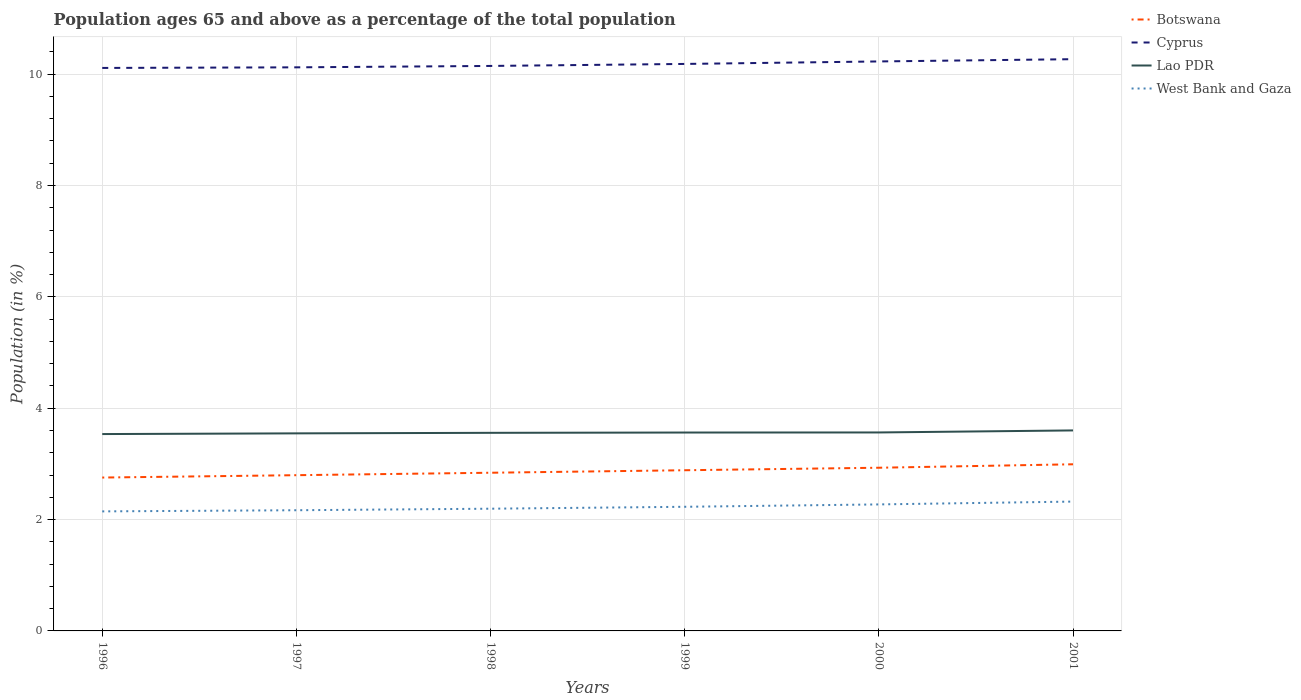How many different coloured lines are there?
Keep it short and to the point. 4. Does the line corresponding to Lao PDR intersect with the line corresponding to Botswana?
Your response must be concise. No. Across all years, what is the maximum percentage of the population ages 65 and above in West Bank and Gaza?
Provide a short and direct response. 2.15. In which year was the percentage of the population ages 65 and above in Cyprus maximum?
Give a very brief answer. 1996. What is the total percentage of the population ages 65 and above in Cyprus in the graph?
Your answer should be very brief. -0.15. What is the difference between the highest and the second highest percentage of the population ages 65 and above in Lao PDR?
Ensure brevity in your answer.  0.07. What is the difference between the highest and the lowest percentage of the population ages 65 and above in West Bank and Gaza?
Your response must be concise. 3. How many lines are there?
Keep it short and to the point. 4. What is the difference between two consecutive major ticks on the Y-axis?
Provide a short and direct response. 2. Does the graph contain grids?
Keep it short and to the point. Yes. Where does the legend appear in the graph?
Provide a short and direct response. Top right. How are the legend labels stacked?
Provide a succinct answer. Vertical. What is the title of the graph?
Your answer should be very brief. Population ages 65 and above as a percentage of the total population. Does "San Marino" appear as one of the legend labels in the graph?
Offer a terse response. No. What is the label or title of the Y-axis?
Provide a short and direct response. Population (in %). What is the Population (in %) in Botswana in 1996?
Ensure brevity in your answer.  2.75. What is the Population (in %) of Cyprus in 1996?
Make the answer very short. 10.11. What is the Population (in %) in Lao PDR in 1996?
Provide a short and direct response. 3.54. What is the Population (in %) of West Bank and Gaza in 1996?
Keep it short and to the point. 2.15. What is the Population (in %) of Botswana in 1997?
Your answer should be very brief. 2.8. What is the Population (in %) of Cyprus in 1997?
Make the answer very short. 10.12. What is the Population (in %) of Lao PDR in 1997?
Offer a terse response. 3.55. What is the Population (in %) in West Bank and Gaza in 1997?
Ensure brevity in your answer.  2.17. What is the Population (in %) of Botswana in 1998?
Your answer should be very brief. 2.84. What is the Population (in %) of Cyprus in 1998?
Your response must be concise. 10.15. What is the Population (in %) in Lao PDR in 1998?
Your response must be concise. 3.56. What is the Population (in %) in West Bank and Gaza in 1998?
Make the answer very short. 2.2. What is the Population (in %) in Botswana in 1999?
Your answer should be very brief. 2.89. What is the Population (in %) in Cyprus in 1999?
Ensure brevity in your answer.  10.18. What is the Population (in %) in Lao PDR in 1999?
Your response must be concise. 3.56. What is the Population (in %) of West Bank and Gaza in 1999?
Make the answer very short. 2.23. What is the Population (in %) in Botswana in 2000?
Your response must be concise. 2.93. What is the Population (in %) in Cyprus in 2000?
Make the answer very short. 10.23. What is the Population (in %) in Lao PDR in 2000?
Keep it short and to the point. 3.56. What is the Population (in %) in West Bank and Gaza in 2000?
Provide a succinct answer. 2.27. What is the Population (in %) of Botswana in 2001?
Offer a very short reply. 2.99. What is the Population (in %) of Cyprus in 2001?
Give a very brief answer. 10.27. What is the Population (in %) of Lao PDR in 2001?
Offer a very short reply. 3.6. What is the Population (in %) of West Bank and Gaza in 2001?
Make the answer very short. 2.32. Across all years, what is the maximum Population (in %) of Botswana?
Your answer should be very brief. 2.99. Across all years, what is the maximum Population (in %) in Cyprus?
Give a very brief answer. 10.27. Across all years, what is the maximum Population (in %) in Lao PDR?
Your answer should be compact. 3.6. Across all years, what is the maximum Population (in %) of West Bank and Gaza?
Your answer should be very brief. 2.32. Across all years, what is the minimum Population (in %) in Botswana?
Offer a terse response. 2.75. Across all years, what is the minimum Population (in %) in Cyprus?
Give a very brief answer. 10.11. Across all years, what is the minimum Population (in %) in Lao PDR?
Make the answer very short. 3.54. Across all years, what is the minimum Population (in %) in West Bank and Gaza?
Provide a short and direct response. 2.15. What is the total Population (in %) of Botswana in the graph?
Make the answer very short. 17.2. What is the total Population (in %) of Cyprus in the graph?
Your response must be concise. 61.06. What is the total Population (in %) of Lao PDR in the graph?
Keep it short and to the point. 21.37. What is the total Population (in %) in West Bank and Gaza in the graph?
Ensure brevity in your answer.  13.34. What is the difference between the Population (in %) in Botswana in 1996 and that in 1997?
Offer a very short reply. -0.04. What is the difference between the Population (in %) of Cyprus in 1996 and that in 1997?
Your response must be concise. -0.01. What is the difference between the Population (in %) in Lao PDR in 1996 and that in 1997?
Your answer should be compact. -0.01. What is the difference between the Population (in %) of West Bank and Gaza in 1996 and that in 1997?
Offer a very short reply. -0.02. What is the difference between the Population (in %) of Botswana in 1996 and that in 1998?
Your answer should be very brief. -0.09. What is the difference between the Population (in %) of Cyprus in 1996 and that in 1998?
Provide a short and direct response. -0.04. What is the difference between the Population (in %) in Lao PDR in 1996 and that in 1998?
Your answer should be very brief. -0.02. What is the difference between the Population (in %) of West Bank and Gaza in 1996 and that in 1998?
Keep it short and to the point. -0.05. What is the difference between the Population (in %) in Botswana in 1996 and that in 1999?
Give a very brief answer. -0.13. What is the difference between the Population (in %) of Cyprus in 1996 and that in 1999?
Ensure brevity in your answer.  -0.07. What is the difference between the Population (in %) of Lao PDR in 1996 and that in 1999?
Provide a short and direct response. -0.03. What is the difference between the Population (in %) of West Bank and Gaza in 1996 and that in 1999?
Your response must be concise. -0.08. What is the difference between the Population (in %) of Botswana in 1996 and that in 2000?
Your response must be concise. -0.18. What is the difference between the Population (in %) of Cyprus in 1996 and that in 2000?
Make the answer very short. -0.12. What is the difference between the Population (in %) in Lao PDR in 1996 and that in 2000?
Your answer should be compact. -0.03. What is the difference between the Population (in %) in West Bank and Gaza in 1996 and that in 2000?
Provide a succinct answer. -0.13. What is the difference between the Population (in %) of Botswana in 1996 and that in 2001?
Your answer should be very brief. -0.24. What is the difference between the Population (in %) of Cyprus in 1996 and that in 2001?
Your response must be concise. -0.16. What is the difference between the Population (in %) in Lao PDR in 1996 and that in 2001?
Your answer should be compact. -0.07. What is the difference between the Population (in %) of West Bank and Gaza in 1996 and that in 2001?
Give a very brief answer. -0.18. What is the difference between the Population (in %) of Botswana in 1997 and that in 1998?
Offer a terse response. -0.04. What is the difference between the Population (in %) of Cyprus in 1997 and that in 1998?
Offer a terse response. -0.03. What is the difference between the Population (in %) in Lao PDR in 1997 and that in 1998?
Your answer should be compact. -0.01. What is the difference between the Population (in %) in West Bank and Gaza in 1997 and that in 1998?
Your response must be concise. -0.03. What is the difference between the Population (in %) of Botswana in 1997 and that in 1999?
Provide a succinct answer. -0.09. What is the difference between the Population (in %) of Cyprus in 1997 and that in 1999?
Your answer should be very brief. -0.06. What is the difference between the Population (in %) of Lao PDR in 1997 and that in 1999?
Offer a terse response. -0.01. What is the difference between the Population (in %) of West Bank and Gaza in 1997 and that in 1999?
Your answer should be compact. -0.06. What is the difference between the Population (in %) of Botswana in 1997 and that in 2000?
Your response must be concise. -0.13. What is the difference between the Population (in %) in Cyprus in 1997 and that in 2000?
Make the answer very short. -0.11. What is the difference between the Population (in %) of Lao PDR in 1997 and that in 2000?
Offer a very short reply. -0.02. What is the difference between the Population (in %) of West Bank and Gaza in 1997 and that in 2000?
Ensure brevity in your answer.  -0.1. What is the difference between the Population (in %) in Botswana in 1997 and that in 2001?
Offer a very short reply. -0.2. What is the difference between the Population (in %) in Cyprus in 1997 and that in 2001?
Offer a terse response. -0.15. What is the difference between the Population (in %) of Lao PDR in 1997 and that in 2001?
Offer a terse response. -0.05. What is the difference between the Population (in %) of West Bank and Gaza in 1997 and that in 2001?
Your answer should be compact. -0.16. What is the difference between the Population (in %) of Botswana in 1998 and that in 1999?
Provide a short and direct response. -0.04. What is the difference between the Population (in %) in Cyprus in 1998 and that in 1999?
Ensure brevity in your answer.  -0.04. What is the difference between the Population (in %) in Lao PDR in 1998 and that in 1999?
Keep it short and to the point. -0.01. What is the difference between the Population (in %) in West Bank and Gaza in 1998 and that in 1999?
Make the answer very short. -0.03. What is the difference between the Population (in %) of Botswana in 1998 and that in 2000?
Offer a terse response. -0.09. What is the difference between the Population (in %) in Cyprus in 1998 and that in 2000?
Keep it short and to the point. -0.08. What is the difference between the Population (in %) in Lao PDR in 1998 and that in 2000?
Offer a terse response. -0.01. What is the difference between the Population (in %) in West Bank and Gaza in 1998 and that in 2000?
Provide a short and direct response. -0.08. What is the difference between the Population (in %) in Botswana in 1998 and that in 2001?
Offer a terse response. -0.15. What is the difference between the Population (in %) of Cyprus in 1998 and that in 2001?
Provide a succinct answer. -0.12. What is the difference between the Population (in %) in Lao PDR in 1998 and that in 2001?
Offer a very short reply. -0.04. What is the difference between the Population (in %) of West Bank and Gaza in 1998 and that in 2001?
Give a very brief answer. -0.13. What is the difference between the Population (in %) of Botswana in 1999 and that in 2000?
Give a very brief answer. -0.04. What is the difference between the Population (in %) in Cyprus in 1999 and that in 2000?
Offer a terse response. -0.04. What is the difference between the Population (in %) of Lao PDR in 1999 and that in 2000?
Make the answer very short. -0. What is the difference between the Population (in %) of West Bank and Gaza in 1999 and that in 2000?
Provide a short and direct response. -0.04. What is the difference between the Population (in %) in Botswana in 1999 and that in 2001?
Your response must be concise. -0.11. What is the difference between the Population (in %) in Cyprus in 1999 and that in 2001?
Offer a very short reply. -0.09. What is the difference between the Population (in %) in Lao PDR in 1999 and that in 2001?
Ensure brevity in your answer.  -0.04. What is the difference between the Population (in %) of West Bank and Gaza in 1999 and that in 2001?
Offer a very short reply. -0.09. What is the difference between the Population (in %) in Botswana in 2000 and that in 2001?
Keep it short and to the point. -0.06. What is the difference between the Population (in %) of Cyprus in 2000 and that in 2001?
Your response must be concise. -0.04. What is the difference between the Population (in %) in Lao PDR in 2000 and that in 2001?
Keep it short and to the point. -0.04. What is the difference between the Population (in %) of West Bank and Gaza in 2000 and that in 2001?
Your answer should be compact. -0.05. What is the difference between the Population (in %) of Botswana in 1996 and the Population (in %) of Cyprus in 1997?
Your answer should be very brief. -7.37. What is the difference between the Population (in %) of Botswana in 1996 and the Population (in %) of Lao PDR in 1997?
Keep it short and to the point. -0.79. What is the difference between the Population (in %) of Botswana in 1996 and the Population (in %) of West Bank and Gaza in 1997?
Ensure brevity in your answer.  0.59. What is the difference between the Population (in %) of Cyprus in 1996 and the Population (in %) of Lao PDR in 1997?
Ensure brevity in your answer.  6.56. What is the difference between the Population (in %) in Cyprus in 1996 and the Population (in %) in West Bank and Gaza in 1997?
Ensure brevity in your answer.  7.94. What is the difference between the Population (in %) in Lao PDR in 1996 and the Population (in %) in West Bank and Gaza in 1997?
Your answer should be very brief. 1.37. What is the difference between the Population (in %) in Botswana in 1996 and the Population (in %) in Cyprus in 1998?
Your answer should be compact. -7.39. What is the difference between the Population (in %) in Botswana in 1996 and the Population (in %) in Lao PDR in 1998?
Ensure brevity in your answer.  -0.8. What is the difference between the Population (in %) in Botswana in 1996 and the Population (in %) in West Bank and Gaza in 1998?
Keep it short and to the point. 0.56. What is the difference between the Population (in %) in Cyprus in 1996 and the Population (in %) in Lao PDR in 1998?
Your answer should be compact. 6.55. What is the difference between the Population (in %) of Cyprus in 1996 and the Population (in %) of West Bank and Gaza in 1998?
Provide a succinct answer. 7.92. What is the difference between the Population (in %) in Lao PDR in 1996 and the Population (in %) in West Bank and Gaza in 1998?
Offer a terse response. 1.34. What is the difference between the Population (in %) of Botswana in 1996 and the Population (in %) of Cyprus in 1999?
Make the answer very short. -7.43. What is the difference between the Population (in %) in Botswana in 1996 and the Population (in %) in Lao PDR in 1999?
Offer a terse response. -0.81. What is the difference between the Population (in %) of Botswana in 1996 and the Population (in %) of West Bank and Gaza in 1999?
Make the answer very short. 0.53. What is the difference between the Population (in %) of Cyprus in 1996 and the Population (in %) of Lao PDR in 1999?
Offer a terse response. 6.55. What is the difference between the Population (in %) of Cyprus in 1996 and the Population (in %) of West Bank and Gaza in 1999?
Your answer should be compact. 7.88. What is the difference between the Population (in %) of Lao PDR in 1996 and the Population (in %) of West Bank and Gaza in 1999?
Give a very brief answer. 1.31. What is the difference between the Population (in %) in Botswana in 1996 and the Population (in %) in Cyprus in 2000?
Your response must be concise. -7.47. What is the difference between the Population (in %) in Botswana in 1996 and the Population (in %) in Lao PDR in 2000?
Provide a succinct answer. -0.81. What is the difference between the Population (in %) in Botswana in 1996 and the Population (in %) in West Bank and Gaza in 2000?
Offer a terse response. 0.48. What is the difference between the Population (in %) in Cyprus in 1996 and the Population (in %) in Lao PDR in 2000?
Ensure brevity in your answer.  6.55. What is the difference between the Population (in %) of Cyprus in 1996 and the Population (in %) of West Bank and Gaza in 2000?
Provide a short and direct response. 7.84. What is the difference between the Population (in %) of Lao PDR in 1996 and the Population (in %) of West Bank and Gaza in 2000?
Your response must be concise. 1.26. What is the difference between the Population (in %) of Botswana in 1996 and the Population (in %) of Cyprus in 2001?
Your answer should be compact. -7.51. What is the difference between the Population (in %) of Botswana in 1996 and the Population (in %) of Lao PDR in 2001?
Offer a very short reply. -0.85. What is the difference between the Population (in %) in Botswana in 1996 and the Population (in %) in West Bank and Gaza in 2001?
Keep it short and to the point. 0.43. What is the difference between the Population (in %) in Cyprus in 1996 and the Population (in %) in Lao PDR in 2001?
Offer a very short reply. 6.51. What is the difference between the Population (in %) in Cyprus in 1996 and the Population (in %) in West Bank and Gaza in 2001?
Provide a succinct answer. 7.79. What is the difference between the Population (in %) of Lao PDR in 1996 and the Population (in %) of West Bank and Gaza in 2001?
Ensure brevity in your answer.  1.21. What is the difference between the Population (in %) of Botswana in 1997 and the Population (in %) of Cyprus in 1998?
Make the answer very short. -7.35. What is the difference between the Population (in %) of Botswana in 1997 and the Population (in %) of Lao PDR in 1998?
Offer a terse response. -0.76. What is the difference between the Population (in %) of Botswana in 1997 and the Population (in %) of West Bank and Gaza in 1998?
Provide a short and direct response. 0.6. What is the difference between the Population (in %) of Cyprus in 1997 and the Population (in %) of Lao PDR in 1998?
Keep it short and to the point. 6.56. What is the difference between the Population (in %) of Cyprus in 1997 and the Population (in %) of West Bank and Gaza in 1998?
Keep it short and to the point. 7.93. What is the difference between the Population (in %) of Lao PDR in 1997 and the Population (in %) of West Bank and Gaza in 1998?
Offer a very short reply. 1.35. What is the difference between the Population (in %) in Botswana in 1997 and the Population (in %) in Cyprus in 1999?
Give a very brief answer. -7.39. What is the difference between the Population (in %) in Botswana in 1997 and the Population (in %) in Lao PDR in 1999?
Make the answer very short. -0.77. What is the difference between the Population (in %) of Botswana in 1997 and the Population (in %) of West Bank and Gaza in 1999?
Provide a succinct answer. 0.57. What is the difference between the Population (in %) in Cyprus in 1997 and the Population (in %) in Lao PDR in 1999?
Offer a very short reply. 6.56. What is the difference between the Population (in %) of Cyprus in 1997 and the Population (in %) of West Bank and Gaza in 1999?
Give a very brief answer. 7.89. What is the difference between the Population (in %) of Lao PDR in 1997 and the Population (in %) of West Bank and Gaza in 1999?
Ensure brevity in your answer.  1.32. What is the difference between the Population (in %) in Botswana in 1997 and the Population (in %) in Cyprus in 2000?
Your answer should be very brief. -7.43. What is the difference between the Population (in %) of Botswana in 1997 and the Population (in %) of Lao PDR in 2000?
Your response must be concise. -0.77. What is the difference between the Population (in %) in Botswana in 1997 and the Population (in %) in West Bank and Gaza in 2000?
Offer a terse response. 0.53. What is the difference between the Population (in %) in Cyprus in 1997 and the Population (in %) in Lao PDR in 2000?
Your answer should be compact. 6.56. What is the difference between the Population (in %) in Cyprus in 1997 and the Population (in %) in West Bank and Gaza in 2000?
Provide a short and direct response. 7.85. What is the difference between the Population (in %) of Lao PDR in 1997 and the Population (in %) of West Bank and Gaza in 2000?
Provide a short and direct response. 1.28. What is the difference between the Population (in %) in Botswana in 1997 and the Population (in %) in Cyprus in 2001?
Your answer should be compact. -7.47. What is the difference between the Population (in %) of Botswana in 1997 and the Population (in %) of Lao PDR in 2001?
Your answer should be compact. -0.8. What is the difference between the Population (in %) in Botswana in 1997 and the Population (in %) in West Bank and Gaza in 2001?
Give a very brief answer. 0.47. What is the difference between the Population (in %) in Cyprus in 1997 and the Population (in %) in Lao PDR in 2001?
Your response must be concise. 6.52. What is the difference between the Population (in %) in Cyprus in 1997 and the Population (in %) in West Bank and Gaza in 2001?
Your response must be concise. 7.8. What is the difference between the Population (in %) in Lao PDR in 1997 and the Population (in %) in West Bank and Gaza in 2001?
Make the answer very short. 1.23. What is the difference between the Population (in %) of Botswana in 1998 and the Population (in %) of Cyprus in 1999?
Give a very brief answer. -7.34. What is the difference between the Population (in %) in Botswana in 1998 and the Population (in %) in Lao PDR in 1999?
Provide a short and direct response. -0.72. What is the difference between the Population (in %) in Botswana in 1998 and the Population (in %) in West Bank and Gaza in 1999?
Offer a terse response. 0.61. What is the difference between the Population (in %) of Cyprus in 1998 and the Population (in %) of Lao PDR in 1999?
Your response must be concise. 6.58. What is the difference between the Population (in %) in Cyprus in 1998 and the Population (in %) in West Bank and Gaza in 1999?
Give a very brief answer. 7.92. What is the difference between the Population (in %) of Lao PDR in 1998 and the Population (in %) of West Bank and Gaza in 1999?
Your answer should be compact. 1.33. What is the difference between the Population (in %) in Botswana in 1998 and the Population (in %) in Cyprus in 2000?
Keep it short and to the point. -7.39. What is the difference between the Population (in %) in Botswana in 1998 and the Population (in %) in Lao PDR in 2000?
Provide a succinct answer. -0.72. What is the difference between the Population (in %) of Botswana in 1998 and the Population (in %) of West Bank and Gaza in 2000?
Provide a succinct answer. 0.57. What is the difference between the Population (in %) of Cyprus in 1998 and the Population (in %) of Lao PDR in 2000?
Your answer should be compact. 6.58. What is the difference between the Population (in %) of Cyprus in 1998 and the Population (in %) of West Bank and Gaza in 2000?
Your answer should be compact. 7.88. What is the difference between the Population (in %) in Lao PDR in 1998 and the Population (in %) in West Bank and Gaza in 2000?
Provide a short and direct response. 1.29. What is the difference between the Population (in %) in Botswana in 1998 and the Population (in %) in Cyprus in 2001?
Your response must be concise. -7.43. What is the difference between the Population (in %) in Botswana in 1998 and the Population (in %) in Lao PDR in 2001?
Offer a terse response. -0.76. What is the difference between the Population (in %) of Botswana in 1998 and the Population (in %) of West Bank and Gaza in 2001?
Make the answer very short. 0.52. What is the difference between the Population (in %) of Cyprus in 1998 and the Population (in %) of Lao PDR in 2001?
Your answer should be very brief. 6.55. What is the difference between the Population (in %) in Cyprus in 1998 and the Population (in %) in West Bank and Gaza in 2001?
Your response must be concise. 7.82. What is the difference between the Population (in %) of Lao PDR in 1998 and the Population (in %) of West Bank and Gaza in 2001?
Offer a very short reply. 1.23. What is the difference between the Population (in %) of Botswana in 1999 and the Population (in %) of Cyprus in 2000?
Ensure brevity in your answer.  -7.34. What is the difference between the Population (in %) in Botswana in 1999 and the Population (in %) in Lao PDR in 2000?
Provide a short and direct response. -0.68. What is the difference between the Population (in %) in Botswana in 1999 and the Population (in %) in West Bank and Gaza in 2000?
Give a very brief answer. 0.61. What is the difference between the Population (in %) in Cyprus in 1999 and the Population (in %) in Lao PDR in 2000?
Keep it short and to the point. 6.62. What is the difference between the Population (in %) in Cyprus in 1999 and the Population (in %) in West Bank and Gaza in 2000?
Offer a very short reply. 7.91. What is the difference between the Population (in %) of Lao PDR in 1999 and the Population (in %) of West Bank and Gaza in 2000?
Make the answer very short. 1.29. What is the difference between the Population (in %) of Botswana in 1999 and the Population (in %) of Cyprus in 2001?
Provide a succinct answer. -7.38. What is the difference between the Population (in %) in Botswana in 1999 and the Population (in %) in Lao PDR in 2001?
Give a very brief answer. -0.72. What is the difference between the Population (in %) of Botswana in 1999 and the Population (in %) of West Bank and Gaza in 2001?
Offer a very short reply. 0.56. What is the difference between the Population (in %) in Cyprus in 1999 and the Population (in %) in Lao PDR in 2001?
Your answer should be very brief. 6.58. What is the difference between the Population (in %) in Cyprus in 1999 and the Population (in %) in West Bank and Gaza in 2001?
Your answer should be very brief. 7.86. What is the difference between the Population (in %) of Lao PDR in 1999 and the Population (in %) of West Bank and Gaza in 2001?
Provide a short and direct response. 1.24. What is the difference between the Population (in %) in Botswana in 2000 and the Population (in %) in Cyprus in 2001?
Keep it short and to the point. -7.34. What is the difference between the Population (in %) of Botswana in 2000 and the Population (in %) of Lao PDR in 2001?
Give a very brief answer. -0.67. What is the difference between the Population (in %) in Botswana in 2000 and the Population (in %) in West Bank and Gaza in 2001?
Make the answer very short. 0.61. What is the difference between the Population (in %) of Cyprus in 2000 and the Population (in %) of Lao PDR in 2001?
Make the answer very short. 6.63. What is the difference between the Population (in %) in Cyprus in 2000 and the Population (in %) in West Bank and Gaza in 2001?
Your response must be concise. 7.91. What is the difference between the Population (in %) in Lao PDR in 2000 and the Population (in %) in West Bank and Gaza in 2001?
Your response must be concise. 1.24. What is the average Population (in %) in Botswana per year?
Keep it short and to the point. 2.87. What is the average Population (in %) of Cyprus per year?
Give a very brief answer. 10.18. What is the average Population (in %) in Lao PDR per year?
Provide a short and direct response. 3.56. What is the average Population (in %) in West Bank and Gaza per year?
Offer a terse response. 2.22. In the year 1996, what is the difference between the Population (in %) of Botswana and Population (in %) of Cyprus?
Your answer should be very brief. -7.36. In the year 1996, what is the difference between the Population (in %) of Botswana and Population (in %) of Lao PDR?
Ensure brevity in your answer.  -0.78. In the year 1996, what is the difference between the Population (in %) of Botswana and Population (in %) of West Bank and Gaza?
Your response must be concise. 0.61. In the year 1996, what is the difference between the Population (in %) of Cyprus and Population (in %) of Lao PDR?
Your answer should be very brief. 6.58. In the year 1996, what is the difference between the Population (in %) of Cyprus and Population (in %) of West Bank and Gaza?
Your answer should be compact. 7.96. In the year 1996, what is the difference between the Population (in %) in Lao PDR and Population (in %) in West Bank and Gaza?
Make the answer very short. 1.39. In the year 1997, what is the difference between the Population (in %) of Botswana and Population (in %) of Cyprus?
Your response must be concise. -7.33. In the year 1997, what is the difference between the Population (in %) of Botswana and Population (in %) of Lao PDR?
Keep it short and to the point. -0.75. In the year 1997, what is the difference between the Population (in %) in Botswana and Population (in %) in West Bank and Gaza?
Provide a short and direct response. 0.63. In the year 1997, what is the difference between the Population (in %) of Cyprus and Population (in %) of Lao PDR?
Your answer should be compact. 6.57. In the year 1997, what is the difference between the Population (in %) of Cyprus and Population (in %) of West Bank and Gaza?
Your answer should be very brief. 7.96. In the year 1997, what is the difference between the Population (in %) of Lao PDR and Population (in %) of West Bank and Gaza?
Ensure brevity in your answer.  1.38. In the year 1998, what is the difference between the Population (in %) of Botswana and Population (in %) of Cyprus?
Ensure brevity in your answer.  -7.31. In the year 1998, what is the difference between the Population (in %) of Botswana and Population (in %) of Lao PDR?
Provide a succinct answer. -0.72. In the year 1998, what is the difference between the Population (in %) in Botswana and Population (in %) in West Bank and Gaza?
Your answer should be very brief. 0.65. In the year 1998, what is the difference between the Population (in %) in Cyprus and Population (in %) in Lao PDR?
Your response must be concise. 6.59. In the year 1998, what is the difference between the Population (in %) in Cyprus and Population (in %) in West Bank and Gaza?
Ensure brevity in your answer.  7.95. In the year 1998, what is the difference between the Population (in %) in Lao PDR and Population (in %) in West Bank and Gaza?
Give a very brief answer. 1.36. In the year 1999, what is the difference between the Population (in %) in Botswana and Population (in %) in Cyprus?
Your answer should be compact. -7.3. In the year 1999, what is the difference between the Population (in %) in Botswana and Population (in %) in Lao PDR?
Your answer should be very brief. -0.68. In the year 1999, what is the difference between the Population (in %) in Botswana and Population (in %) in West Bank and Gaza?
Provide a short and direct response. 0.66. In the year 1999, what is the difference between the Population (in %) in Cyprus and Population (in %) in Lao PDR?
Keep it short and to the point. 6.62. In the year 1999, what is the difference between the Population (in %) of Cyprus and Population (in %) of West Bank and Gaza?
Give a very brief answer. 7.95. In the year 1999, what is the difference between the Population (in %) in Lao PDR and Population (in %) in West Bank and Gaza?
Your answer should be compact. 1.33. In the year 2000, what is the difference between the Population (in %) of Botswana and Population (in %) of Cyprus?
Offer a terse response. -7.3. In the year 2000, what is the difference between the Population (in %) of Botswana and Population (in %) of Lao PDR?
Keep it short and to the point. -0.63. In the year 2000, what is the difference between the Population (in %) in Botswana and Population (in %) in West Bank and Gaza?
Your answer should be very brief. 0.66. In the year 2000, what is the difference between the Population (in %) of Cyprus and Population (in %) of Lao PDR?
Provide a succinct answer. 6.66. In the year 2000, what is the difference between the Population (in %) in Cyprus and Population (in %) in West Bank and Gaza?
Provide a short and direct response. 7.96. In the year 2000, what is the difference between the Population (in %) in Lao PDR and Population (in %) in West Bank and Gaza?
Your answer should be very brief. 1.29. In the year 2001, what is the difference between the Population (in %) in Botswana and Population (in %) in Cyprus?
Your answer should be very brief. -7.28. In the year 2001, what is the difference between the Population (in %) of Botswana and Population (in %) of Lao PDR?
Offer a terse response. -0.61. In the year 2001, what is the difference between the Population (in %) in Botswana and Population (in %) in West Bank and Gaza?
Provide a succinct answer. 0.67. In the year 2001, what is the difference between the Population (in %) in Cyprus and Population (in %) in Lao PDR?
Offer a terse response. 6.67. In the year 2001, what is the difference between the Population (in %) in Cyprus and Population (in %) in West Bank and Gaza?
Offer a very short reply. 7.95. In the year 2001, what is the difference between the Population (in %) in Lao PDR and Population (in %) in West Bank and Gaza?
Your answer should be very brief. 1.28. What is the ratio of the Population (in %) in Botswana in 1996 to that in 1997?
Your answer should be very brief. 0.98. What is the ratio of the Population (in %) in Lao PDR in 1996 to that in 1997?
Your answer should be very brief. 1. What is the ratio of the Population (in %) of West Bank and Gaza in 1996 to that in 1997?
Ensure brevity in your answer.  0.99. What is the ratio of the Population (in %) of Botswana in 1996 to that in 1998?
Make the answer very short. 0.97. What is the ratio of the Population (in %) of Lao PDR in 1996 to that in 1998?
Keep it short and to the point. 0.99. What is the ratio of the Population (in %) in West Bank and Gaza in 1996 to that in 1998?
Give a very brief answer. 0.98. What is the ratio of the Population (in %) of Botswana in 1996 to that in 1999?
Offer a very short reply. 0.95. What is the ratio of the Population (in %) of West Bank and Gaza in 1996 to that in 1999?
Provide a short and direct response. 0.96. What is the ratio of the Population (in %) of Botswana in 1996 to that in 2000?
Keep it short and to the point. 0.94. What is the ratio of the Population (in %) in West Bank and Gaza in 1996 to that in 2000?
Your answer should be compact. 0.94. What is the ratio of the Population (in %) in Botswana in 1996 to that in 2001?
Your response must be concise. 0.92. What is the ratio of the Population (in %) of Cyprus in 1996 to that in 2001?
Your answer should be compact. 0.98. What is the ratio of the Population (in %) of Lao PDR in 1996 to that in 2001?
Your answer should be very brief. 0.98. What is the ratio of the Population (in %) of West Bank and Gaza in 1996 to that in 2001?
Your answer should be compact. 0.92. What is the ratio of the Population (in %) in Botswana in 1997 to that in 1998?
Your answer should be compact. 0.98. What is the ratio of the Population (in %) in Cyprus in 1997 to that in 1998?
Offer a very short reply. 1. What is the ratio of the Population (in %) of Lao PDR in 1997 to that in 1998?
Your answer should be very brief. 1. What is the ratio of the Population (in %) in West Bank and Gaza in 1997 to that in 1998?
Offer a very short reply. 0.99. What is the ratio of the Population (in %) of Botswana in 1997 to that in 1999?
Provide a succinct answer. 0.97. What is the ratio of the Population (in %) in Lao PDR in 1997 to that in 1999?
Ensure brevity in your answer.  1. What is the ratio of the Population (in %) in West Bank and Gaza in 1997 to that in 1999?
Provide a short and direct response. 0.97. What is the ratio of the Population (in %) in Botswana in 1997 to that in 2000?
Provide a succinct answer. 0.95. What is the ratio of the Population (in %) in West Bank and Gaza in 1997 to that in 2000?
Keep it short and to the point. 0.95. What is the ratio of the Population (in %) of Botswana in 1997 to that in 2001?
Your answer should be compact. 0.93. What is the ratio of the Population (in %) of Cyprus in 1997 to that in 2001?
Your answer should be compact. 0.99. What is the ratio of the Population (in %) of Lao PDR in 1997 to that in 2001?
Provide a short and direct response. 0.99. What is the ratio of the Population (in %) of West Bank and Gaza in 1997 to that in 2001?
Your answer should be very brief. 0.93. What is the ratio of the Population (in %) of Botswana in 1998 to that in 1999?
Your answer should be compact. 0.98. What is the ratio of the Population (in %) in Cyprus in 1998 to that in 1999?
Your response must be concise. 1. What is the ratio of the Population (in %) in West Bank and Gaza in 1998 to that in 1999?
Give a very brief answer. 0.98. What is the ratio of the Population (in %) of Botswana in 1998 to that in 2000?
Offer a very short reply. 0.97. What is the ratio of the Population (in %) in West Bank and Gaza in 1998 to that in 2000?
Provide a short and direct response. 0.97. What is the ratio of the Population (in %) of Botswana in 1998 to that in 2001?
Your answer should be compact. 0.95. What is the ratio of the Population (in %) in West Bank and Gaza in 1998 to that in 2001?
Keep it short and to the point. 0.94. What is the ratio of the Population (in %) of Botswana in 1999 to that in 2000?
Your response must be concise. 0.98. What is the ratio of the Population (in %) of West Bank and Gaza in 1999 to that in 2000?
Ensure brevity in your answer.  0.98. What is the ratio of the Population (in %) of Lao PDR in 1999 to that in 2001?
Make the answer very short. 0.99. What is the ratio of the Population (in %) of West Bank and Gaza in 1999 to that in 2001?
Your response must be concise. 0.96. What is the ratio of the Population (in %) of Botswana in 2000 to that in 2001?
Provide a succinct answer. 0.98. What is the ratio of the Population (in %) of Cyprus in 2000 to that in 2001?
Offer a terse response. 1. What is the ratio of the Population (in %) of Lao PDR in 2000 to that in 2001?
Offer a terse response. 0.99. What is the ratio of the Population (in %) of West Bank and Gaza in 2000 to that in 2001?
Give a very brief answer. 0.98. What is the difference between the highest and the second highest Population (in %) in Botswana?
Offer a very short reply. 0.06. What is the difference between the highest and the second highest Population (in %) of Cyprus?
Your answer should be compact. 0.04. What is the difference between the highest and the second highest Population (in %) of Lao PDR?
Your answer should be compact. 0.04. What is the difference between the highest and the second highest Population (in %) of West Bank and Gaza?
Ensure brevity in your answer.  0.05. What is the difference between the highest and the lowest Population (in %) of Botswana?
Offer a very short reply. 0.24. What is the difference between the highest and the lowest Population (in %) in Cyprus?
Ensure brevity in your answer.  0.16. What is the difference between the highest and the lowest Population (in %) of Lao PDR?
Offer a terse response. 0.07. What is the difference between the highest and the lowest Population (in %) of West Bank and Gaza?
Make the answer very short. 0.18. 